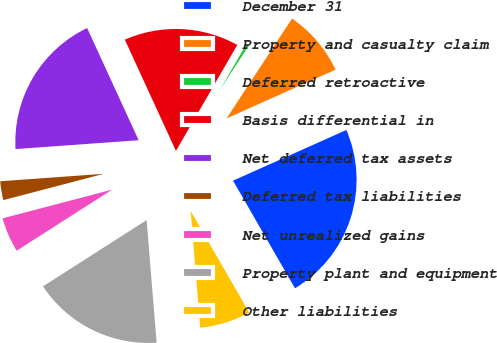Convert chart to OTSL. <chart><loc_0><loc_0><loc_500><loc_500><pie_chart><fcel>December 31<fcel>Property and casualty claim<fcel>Deferred retroactive<fcel>Basis differential in<fcel>Net deferred tax assets<fcel>Deferred tax liabilities<fcel>Net unrealized gains<fcel>Property plant and equipment<fcel>Other liabilities<nl><fcel>23.38%<fcel>9.07%<fcel>0.89%<fcel>15.2%<fcel>19.29%<fcel>2.93%<fcel>4.98%<fcel>17.24%<fcel>7.02%<nl></chart> 